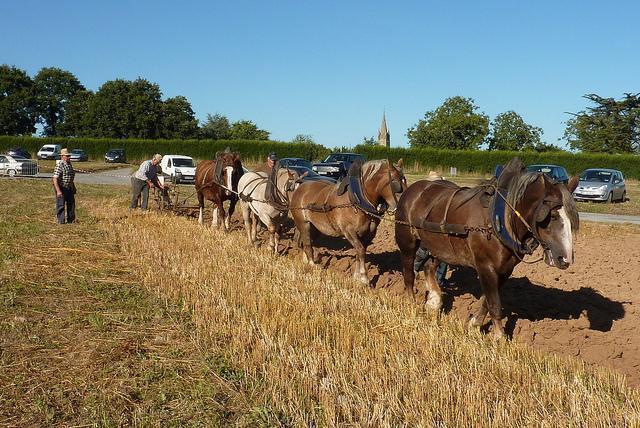Why are horses eyes covered?
Choose the right answer from the provided options to respond to the question.
Options: Superstition, insects, confusion, style. Insects. 